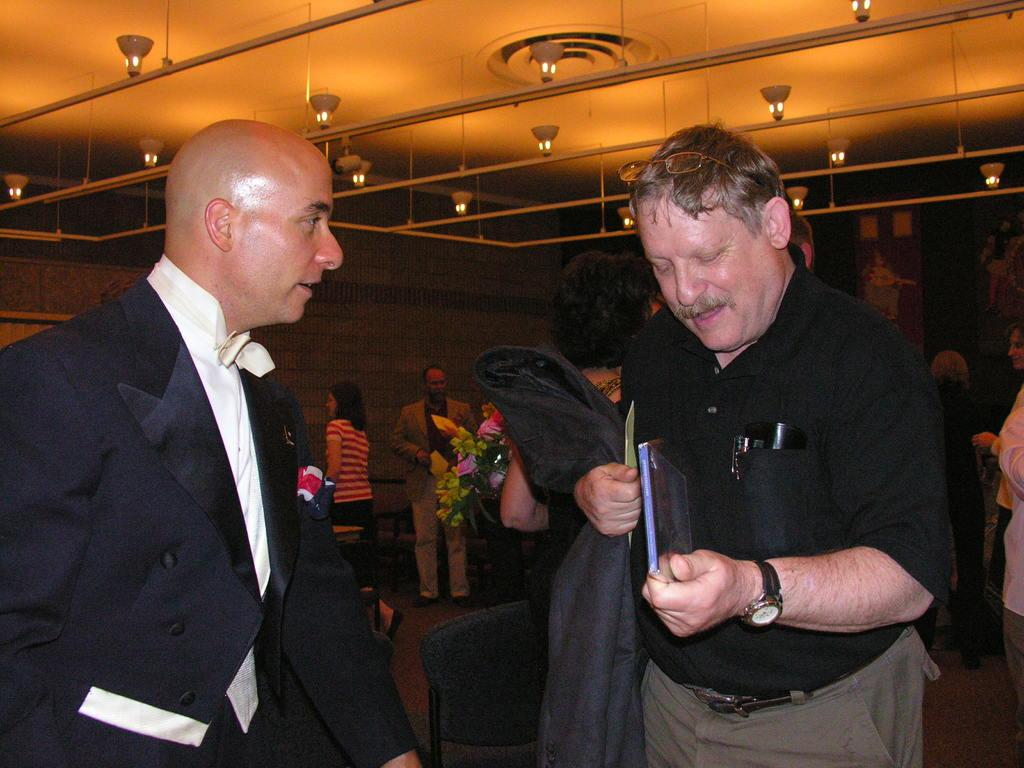How many men are in the image? There are two men in the image. What are the men wearing? The men are wearing black dresses. Can you describe the background of the image? There are people visible in the background of the image. What other elements can be seen in the image? There are flowers and a roof with lights at the top of the image. Are the women in the image attempting to dance in the rain? There are no women present in the image, and it is not raining. 